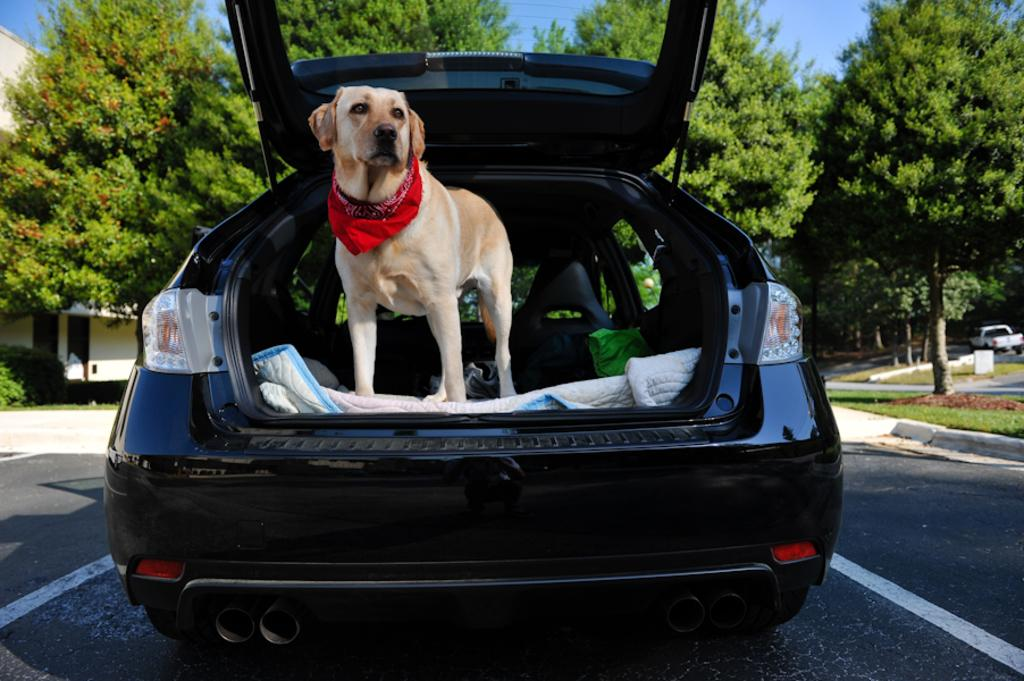What is the dog doing in the image? The dog is standing in a car with the back door open. What can be seen behind the car? Trees are visible behind the car. What is visible in the background of the image? The house is visible in the background. What else is present in the image? A vehicle is present on the road. What type of journey is the dog about to embark on in the image? There is no indication of a journey in the image, as it only shows the dog standing in a car with the door open. Is the dog saying good-bye to someone in the image? There is no indication of the dog saying good-bye to anyone in the image. Can you see a turkey in the image? There is no turkey present in the image. 